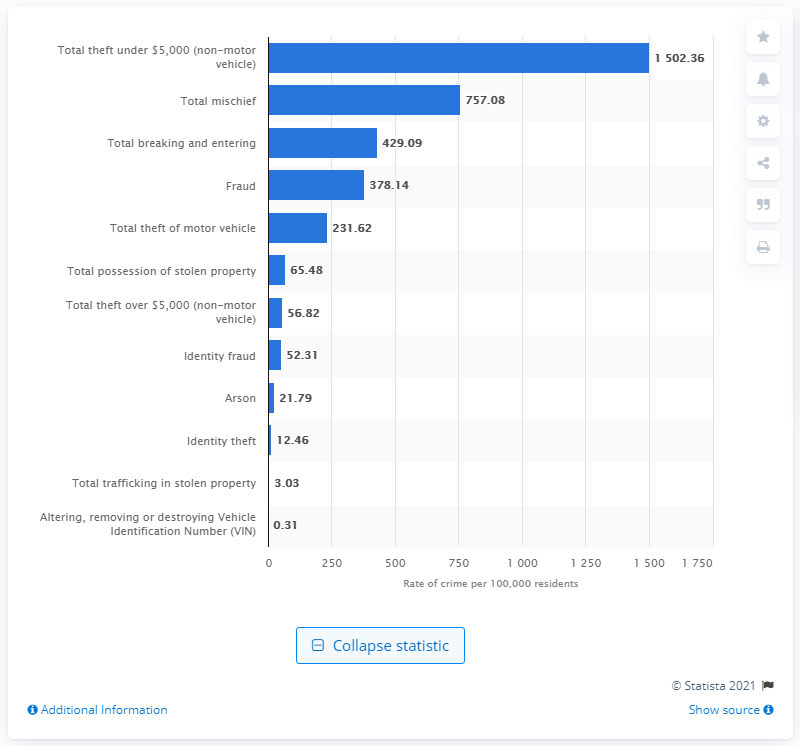How many incidents of mischief were reported per 100,000 residents in Canada in 2019?
 757.08 